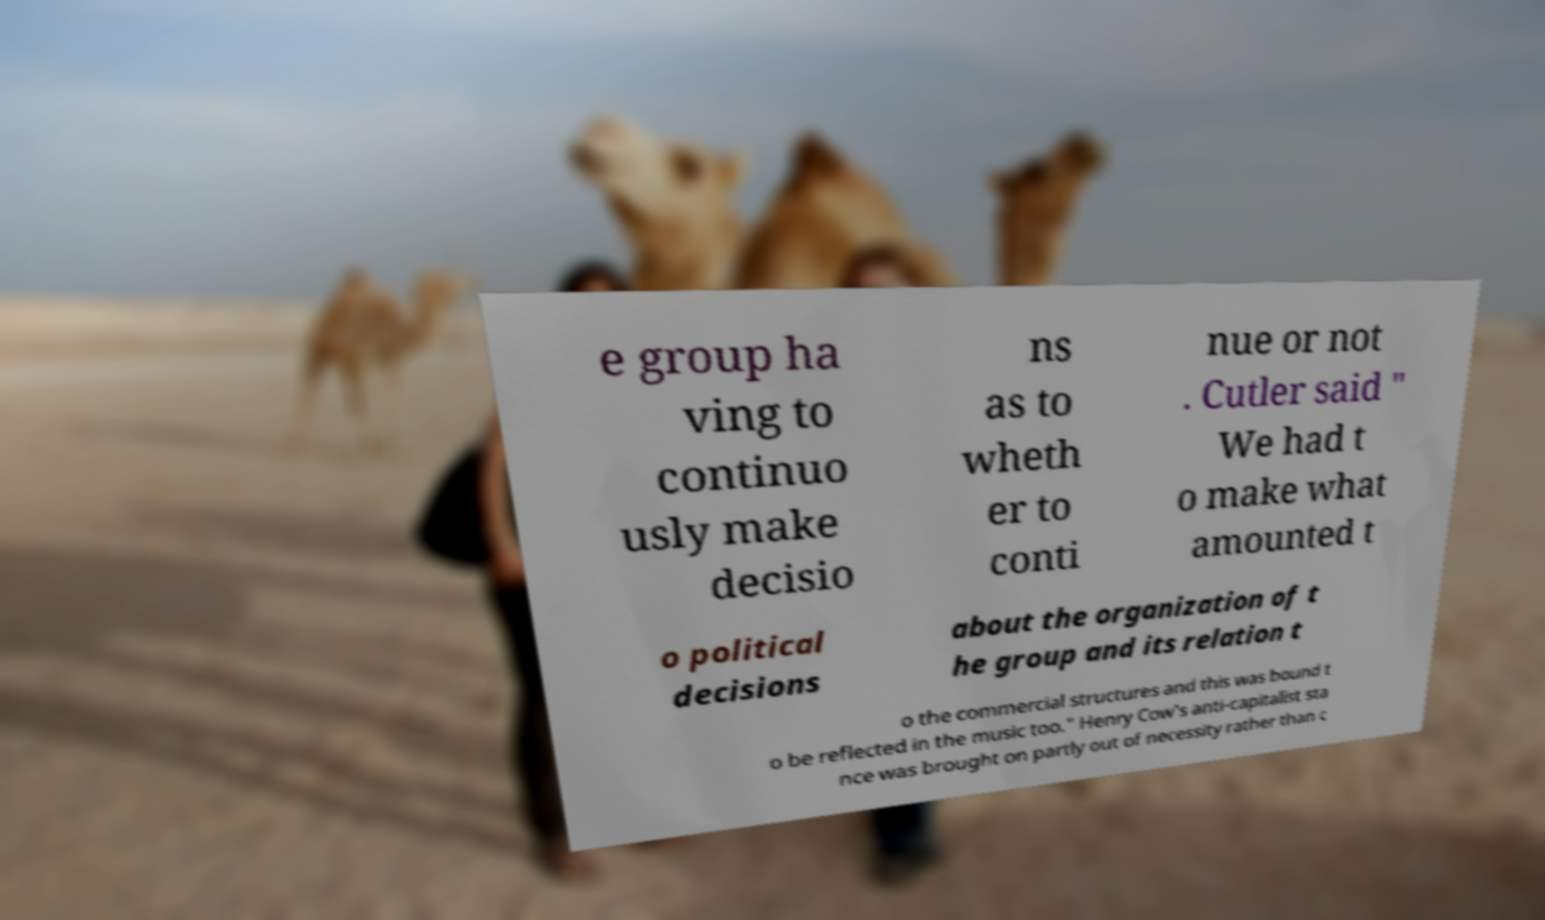Please read and relay the text visible in this image. What does it say? e group ha ving to continuo usly make decisio ns as to wheth er to conti nue or not . Cutler said " We had t o make what amounted t o political decisions about the organization of t he group and its relation t o the commercial structures and this was bound t o be reflected in the music too." Henry Cow's anti-capitalist sta nce was brought on partly out of necessity rather than c 